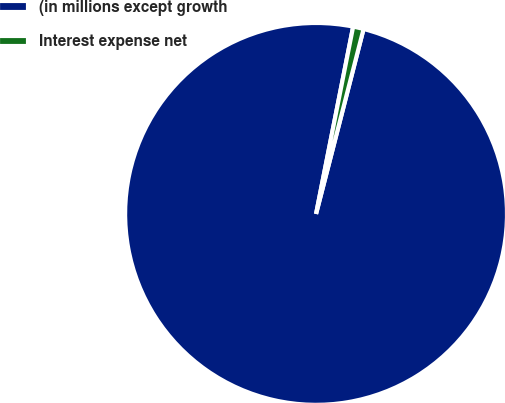Convert chart. <chart><loc_0><loc_0><loc_500><loc_500><pie_chart><fcel>(in millions except growth<fcel>Interest expense net<nl><fcel>99.11%<fcel>0.89%<nl></chart> 